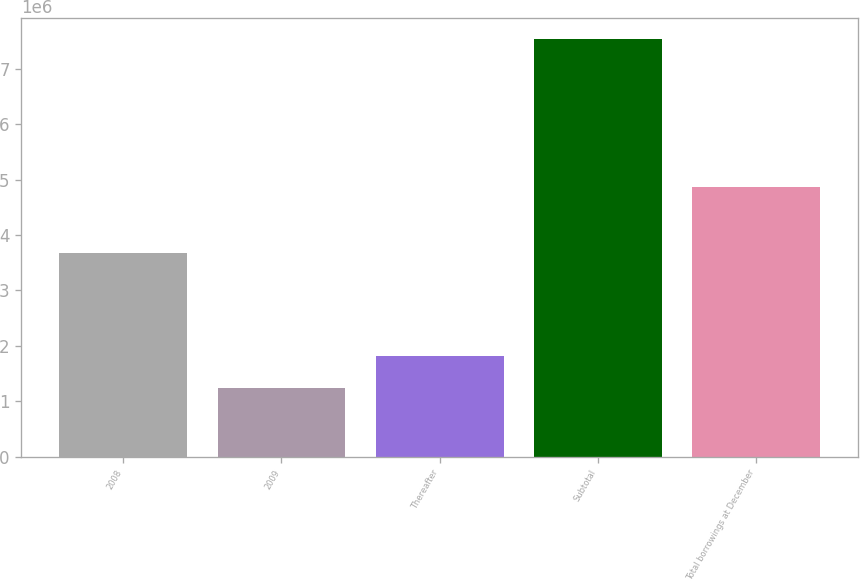Convert chart. <chart><loc_0><loc_0><loc_500><loc_500><bar_chart><fcel>2008<fcel>2009<fcel>Thereafter<fcel>Subtotal<fcel>Total borrowings at December<nl><fcel>3.67e+06<fcel>1.244e+06<fcel>1.81636e+06<fcel>7.53977e+06<fcel>4.86547e+06<nl></chart> 